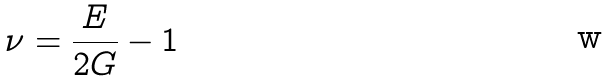<formula> <loc_0><loc_0><loc_500><loc_500>\nu = \frac { E } { 2 G } - 1</formula> 